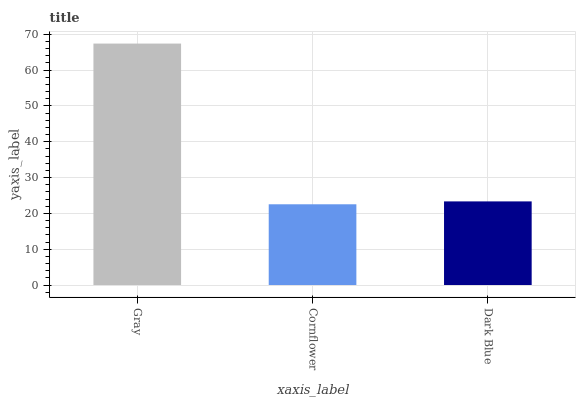Is Cornflower the minimum?
Answer yes or no. Yes. Is Gray the maximum?
Answer yes or no. Yes. Is Dark Blue the minimum?
Answer yes or no. No. Is Dark Blue the maximum?
Answer yes or no. No. Is Dark Blue greater than Cornflower?
Answer yes or no. Yes. Is Cornflower less than Dark Blue?
Answer yes or no. Yes. Is Cornflower greater than Dark Blue?
Answer yes or no. No. Is Dark Blue less than Cornflower?
Answer yes or no. No. Is Dark Blue the high median?
Answer yes or no. Yes. Is Dark Blue the low median?
Answer yes or no. Yes. Is Gray the high median?
Answer yes or no. No. Is Gray the low median?
Answer yes or no. No. 